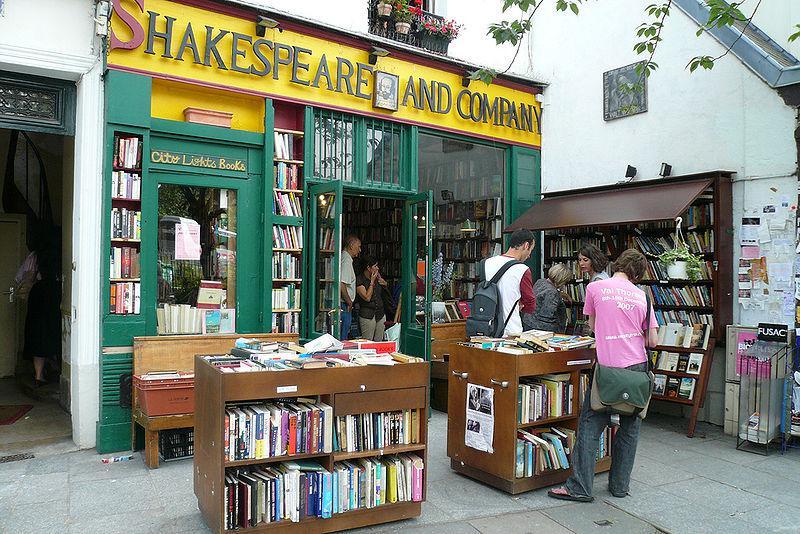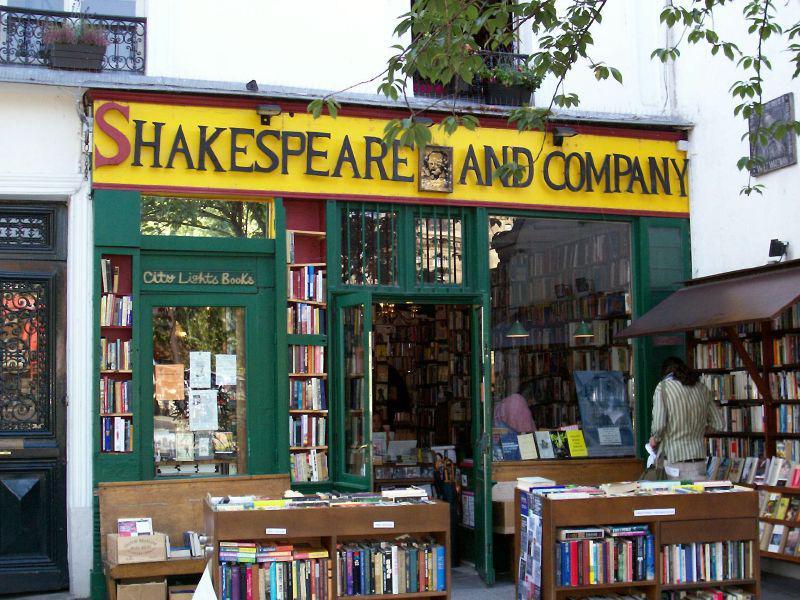The first image is the image on the left, the second image is the image on the right. Assess this claim about the two images: "There are more than two people at the bookstore in one of the images.". Correct or not? Answer yes or no. Yes. The first image is the image on the left, the second image is the image on the right. For the images displayed, is the sentence "Crate-like brown bookshelves stand in front of a green bookstore under its yellow sign." factually correct? Answer yes or no. Yes. 